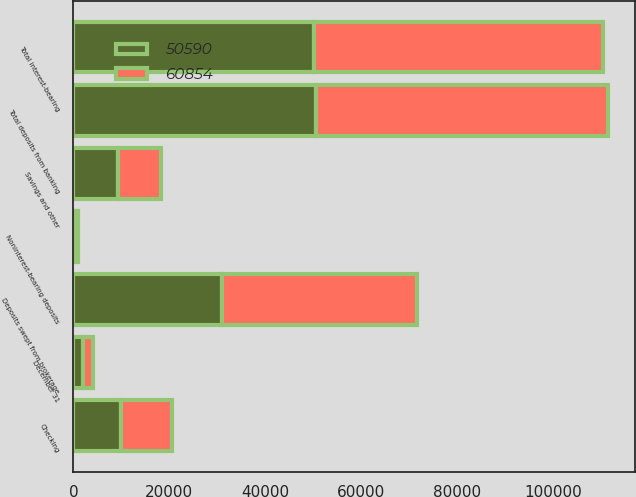Convert chart to OTSL. <chart><loc_0><loc_0><loc_500><loc_500><stacked_bar_chart><ecel><fcel>December 31<fcel>Deposits swept from brokerage<fcel>Checking<fcel>Savings and other<fcel>Total interest-bearing<fcel>Noninterest-bearing deposits<fcel>Total deposits from banking<nl><fcel>60854<fcel>2011<fcel>40617<fcel>10765<fcel>8997<fcel>60379<fcel>475<fcel>60854<nl><fcel>50590<fcel>2010<fcel>30980<fcel>9890<fcel>9241<fcel>50111<fcel>479<fcel>50590<nl></chart> 